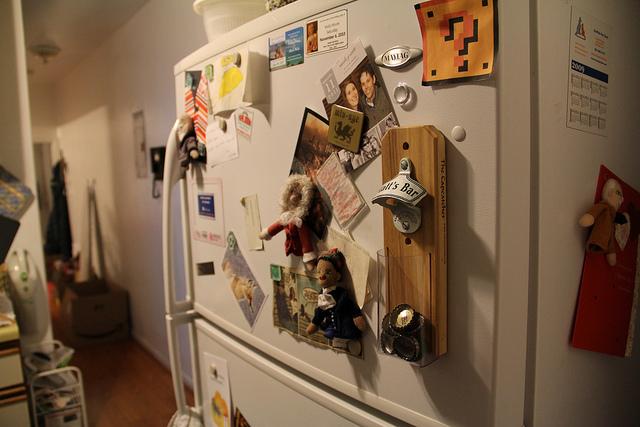What appliance is shown?
Short answer required. Refrigerator. Are the refrigerator handles on the left or right side?
Concise answer only. Left. Are magnets on the fridge?
Keep it brief. Yes. 